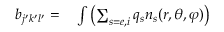<formula> <loc_0><loc_0><loc_500><loc_500>\begin{array} { r l } { b _ { j ^ { \prime } k ^ { \prime } l ^ { \prime } } = } & \int \left ( \sum _ { s = e , i } q _ { s } n _ { s } ( r , \theta , \varphi ) \right ) } \end{array}</formula> 